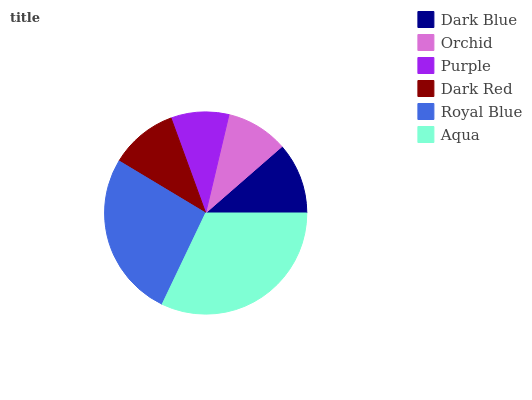Is Purple the minimum?
Answer yes or no. Yes. Is Aqua the maximum?
Answer yes or no. Yes. Is Orchid the minimum?
Answer yes or no. No. Is Orchid the maximum?
Answer yes or no. No. Is Dark Blue greater than Orchid?
Answer yes or no. Yes. Is Orchid less than Dark Blue?
Answer yes or no. Yes. Is Orchid greater than Dark Blue?
Answer yes or no. No. Is Dark Blue less than Orchid?
Answer yes or no. No. Is Dark Blue the high median?
Answer yes or no. Yes. Is Dark Red the low median?
Answer yes or no. Yes. Is Dark Red the high median?
Answer yes or no. No. Is Aqua the low median?
Answer yes or no. No. 